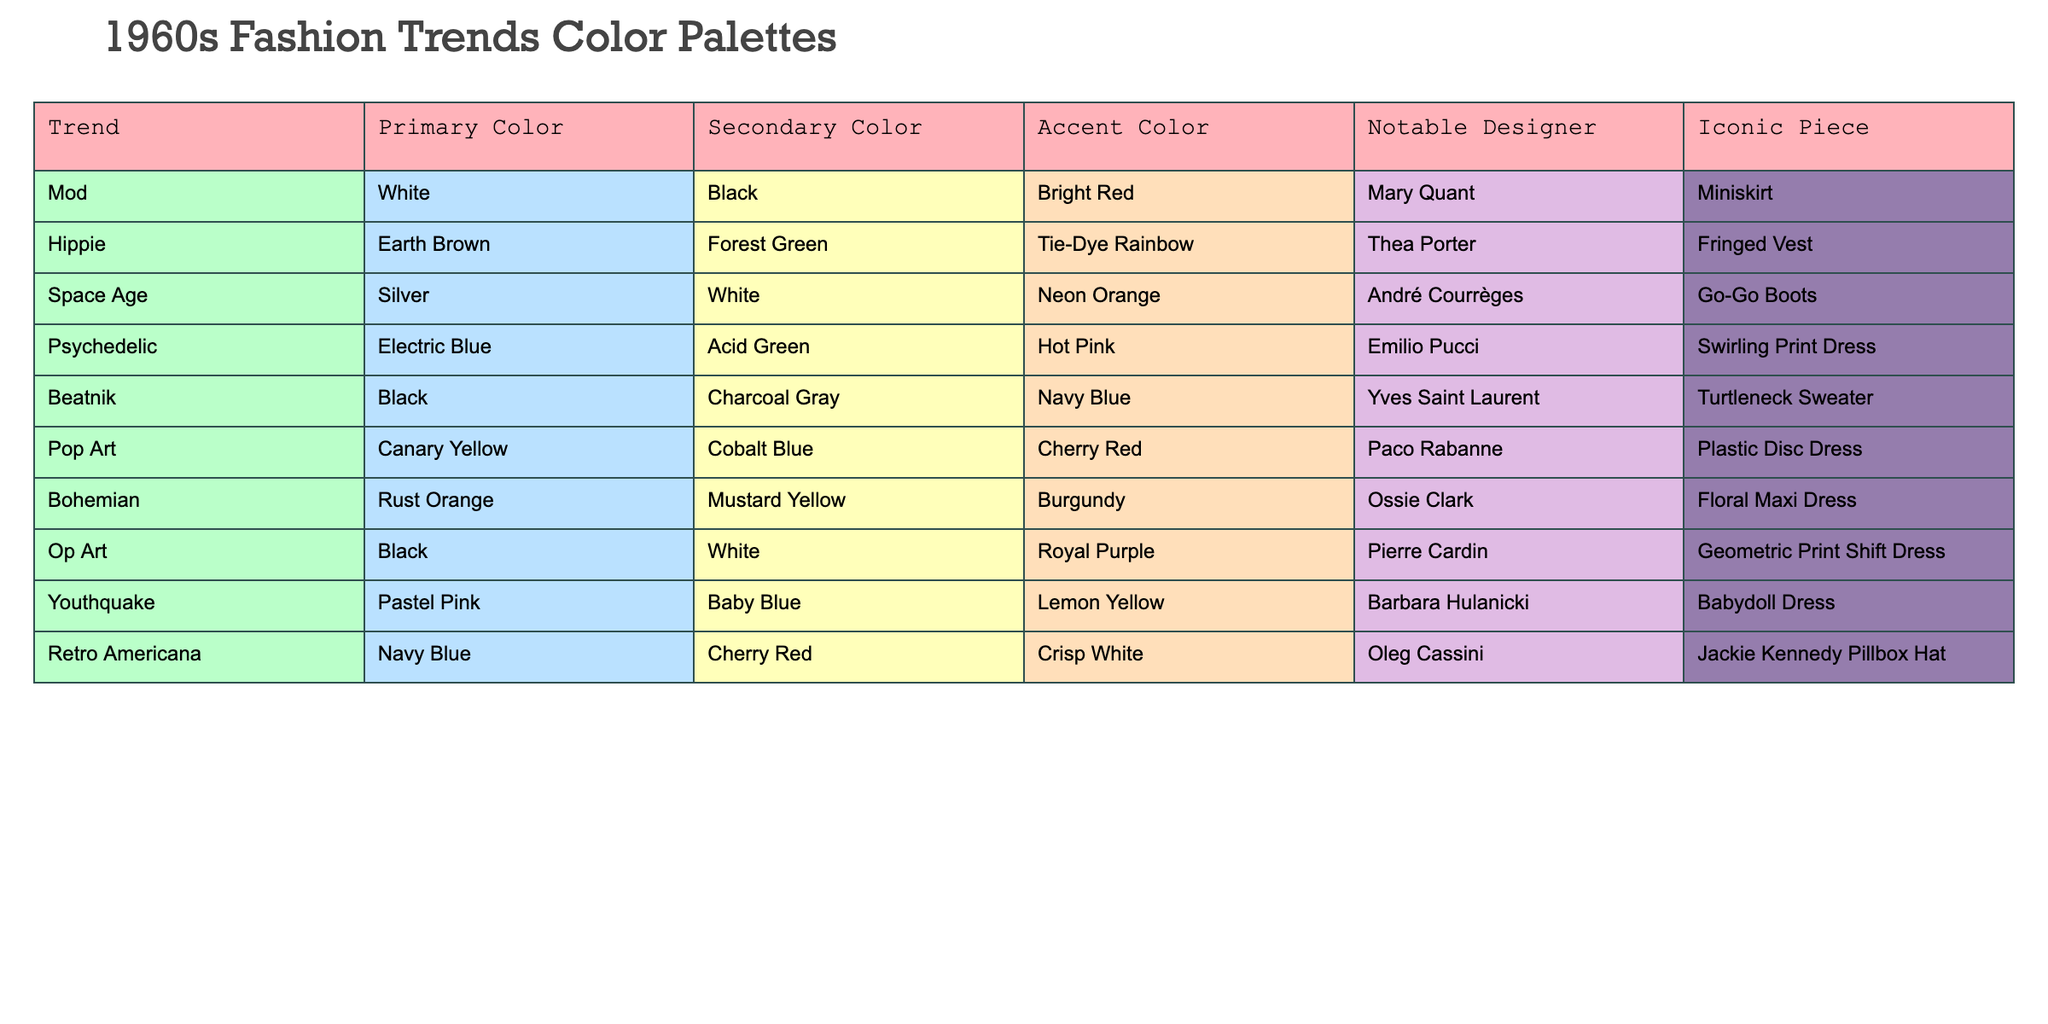What is the primary color used in the Mod trend? The Mod trend has the primary color listed as White in the table.
Answer: White Who designed the iconic piece known as the Miniskirt? The Miniskirt, associated with the Mod trend, was designed by Mary Quant according to the table.
Answer: Mary Quant Which trend features an Accent Color of Lemon Yellow? The Youthquake trend features Lemon Yellow as its Accent Color.
Answer: Youthquake Is there a trend with a Secondary Color of Charcoal Gray? Yes, the Beatnik trend has Charcoal Gray listed as its Secondary Color.
Answer: Yes What is the notable piece associated with the Space Age trend? The notable piece for the Space Age trend is the Go-Go Boots, as per the table information.
Answer: Go-Go Boots Which trend combines Navy Blue and Crisp White as its colors? The Retro Americana trend combines Navy Blue as the Secondary Color and Crisp White as the Accent Color according to the table.
Answer: Retro Americana List all the trends that have Black as either a Primary or Secondary Color. The trends with Black are Mod (Primary), Beatnik (Primary), and Op Art (Primary). In total, there are three trends listed.
Answer: Three trends What is the average number of colors listed for the trends represented in the table? Each trend in the table has three color categories (Primary, Secondary, Accent). There are 10 trends, leading to a total of 30 color entries. The average is 30 colors / 10 trends = 3 colors per trend.
Answer: 3 colors How many trends feature Earthy tones (like Earth Brown or Rust Orange) as a Primary Color? The Hippie trend has Earth Brown and the Bohemian trend has Rust Orange as their Primary Colors. This means there are 2 trends featuring earthy tones.
Answer: 2 trends Which color is used as the Accent Color for the Psychedelic trend? The Psychedelic trend has Hot Pink as its Accent Color.
Answer: Hot Pink 